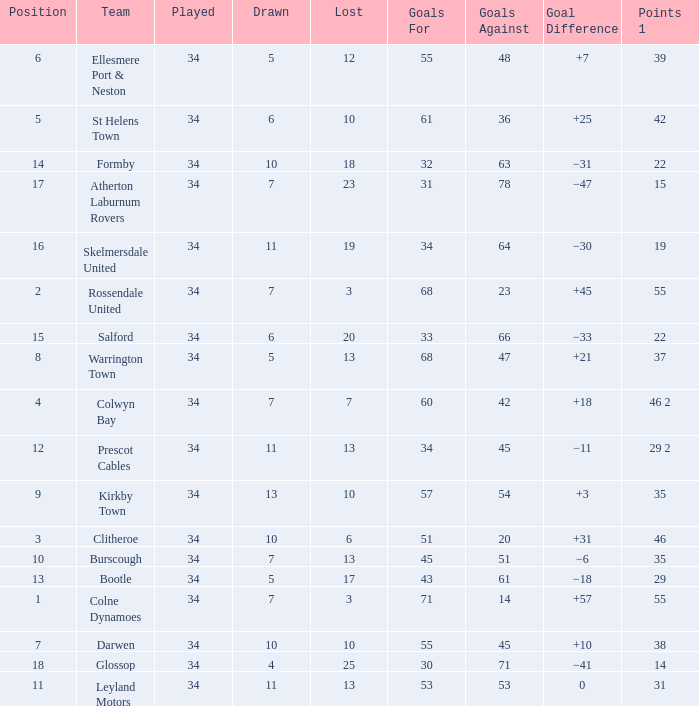How many Drawn have a Lost smaller than 25, and a Goal Difference of +7, and a Played larger than 34? 0.0. 